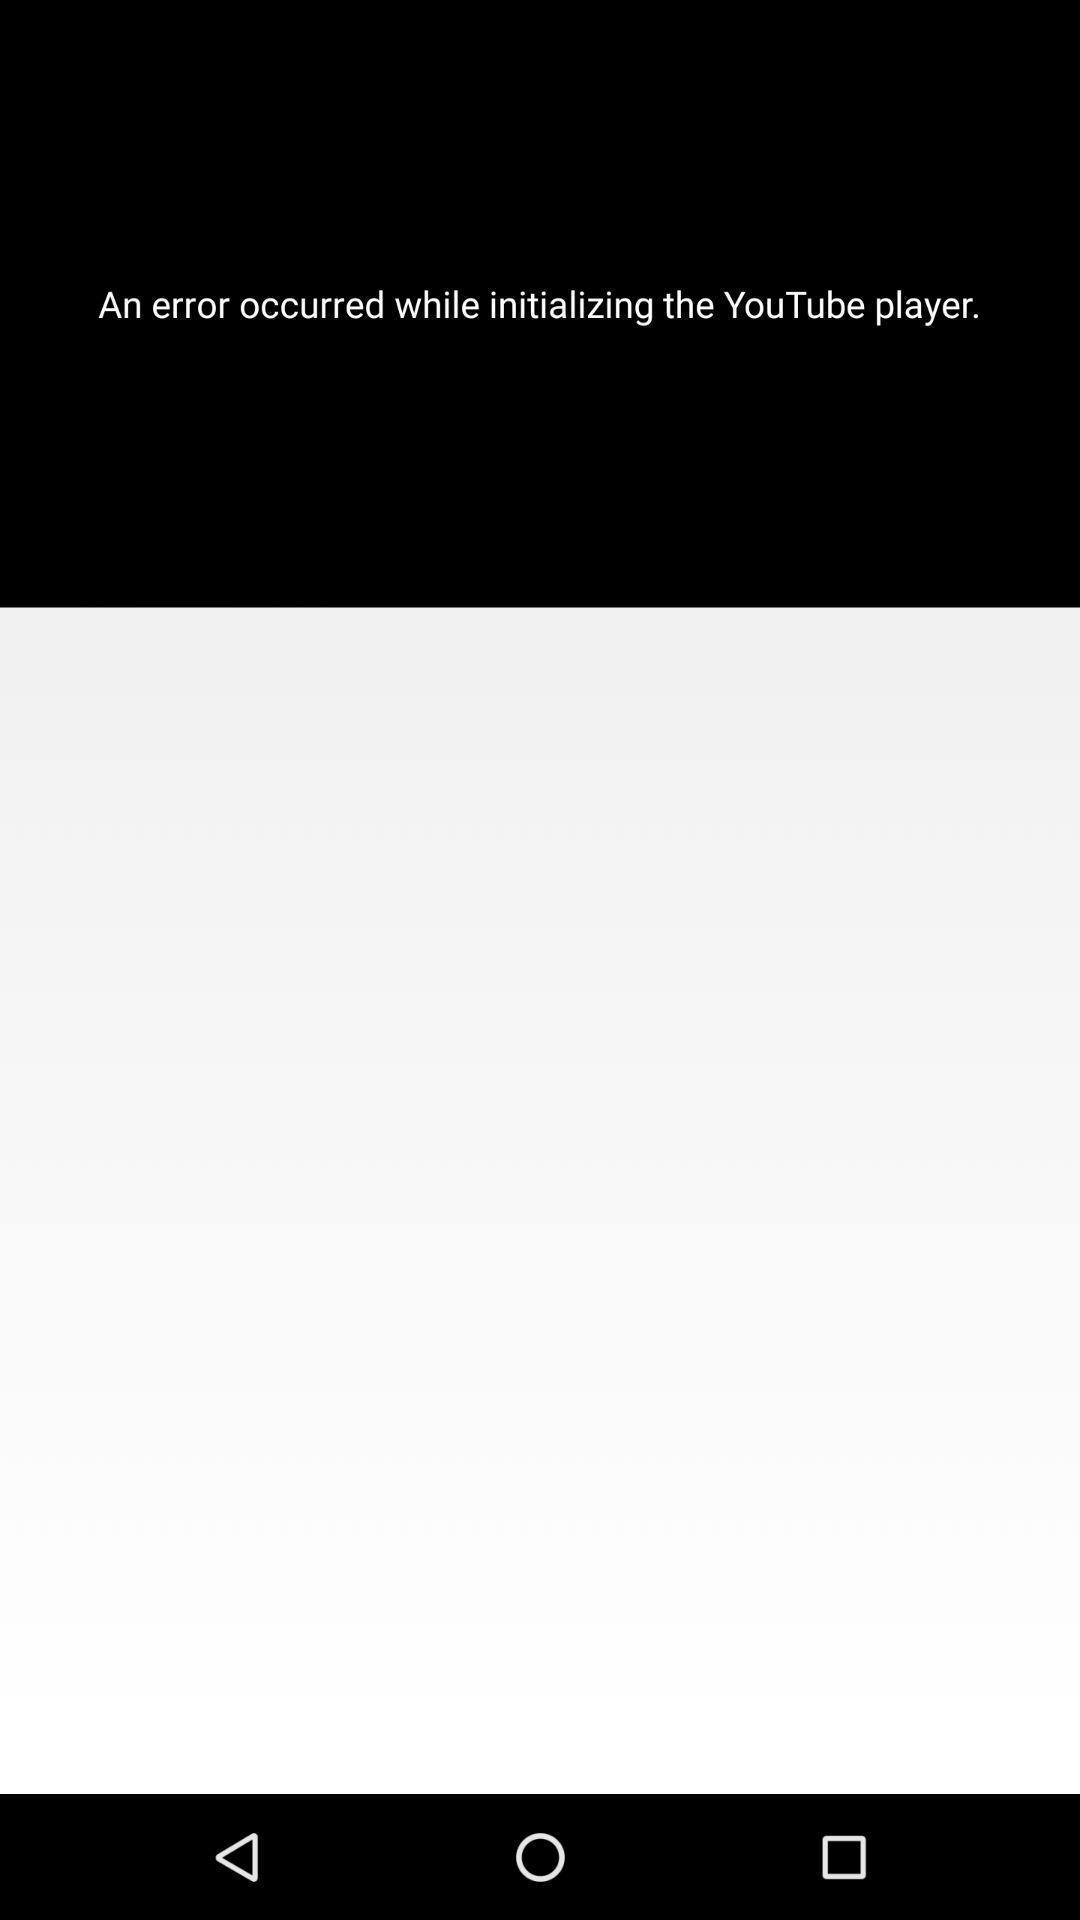Please provide a description for this image. Screen showing an error occurred while initializing a application. 